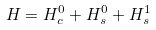Convert formula to latex. <formula><loc_0><loc_0><loc_500><loc_500>H = H _ { c } ^ { 0 } + H _ { s } ^ { 0 } + H _ { s } ^ { 1 }</formula> 